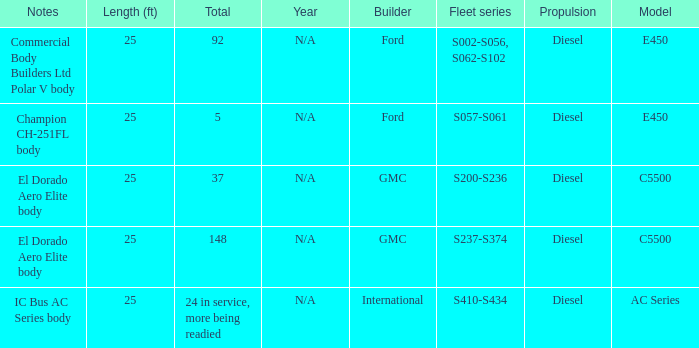What are the notes for Ford when the total is 5? Champion CH-251FL body. Would you mind parsing the complete table? {'header': ['Notes', 'Length (ft)', 'Total', 'Year', 'Builder', 'Fleet series', 'Propulsion', 'Model'], 'rows': [['Commercial Body Builders Ltd Polar V body', '25', '92', 'N/A', 'Ford', 'S002-S056, S062-S102', 'Diesel', 'E450'], ['Champion CH-251FL body', '25', '5', 'N/A', 'Ford', 'S057-S061', 'Diesel', 'E450'], ['El Dorado Aero Elite body', '25', '37', 'N/A', 'GMC', 'S200-S236', 'Diesel', 'C5500'], ['El Dorado Aero Elite body', '25', '148', 'N/A', 'GMC', 'S237-S374', 'Diesel', 'C5500'], ['IC Bus AC Series body', '25', '24 in service, more being readied', 'N/A', 'International', 'S410-S434', 'Diesel', 'AC Series']]} 